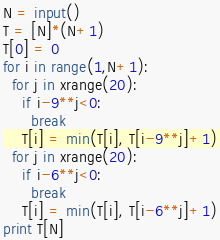<code> <loc_0><loc_0><loc_500><loc_500><_Python_>N = input()
T = [N]*(N+1)
T[0] = 0
for i in range(1,N+1):
  for j in xrange(20):
    if i-9**j<0:
      break
    T[i] = min(T[i], T[i-9**j]+1)
  for j in xrange(20):
    if i-6**j<0:
      break
    T[i] = min(T[i], T[i-6**j]+1)
print T[N]
</code> 